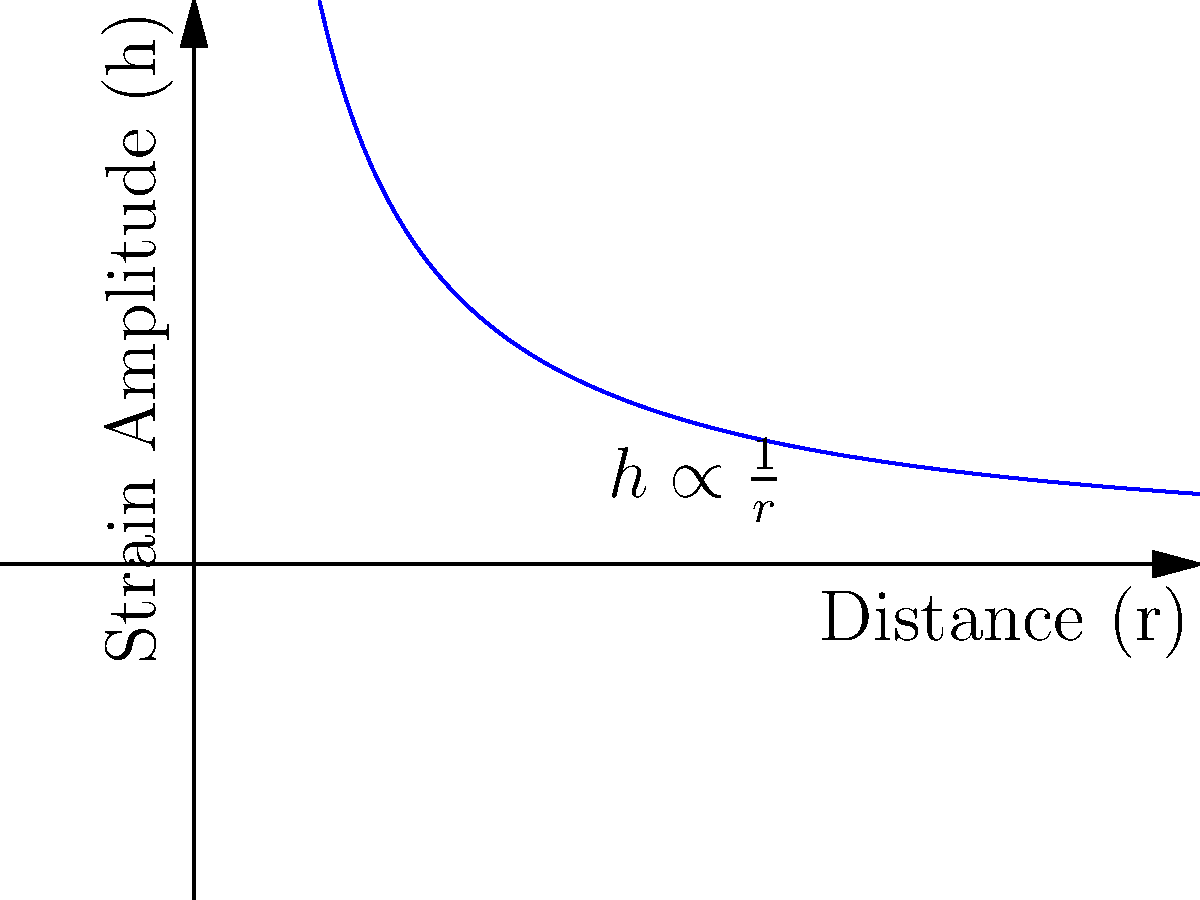Consider a gravitational wave source at a distance $r$ from an observer. If the strain amplitude $h$ of the gravitational wave is inversely proportional to the distance, how would the strain amplitude change if the observer moves to a position that is 3 times farther from the source? Let's approach this step-by-step:

1) We are given that the strain amplitude $h$ is inversely proportional to the distance $r$. This can be expressed mathematically as:

   $h \propto \frac{1}{r}$

2) Let's call the initial distance $r_1$ and the initial strain amplitude $h_1$. We can write:

   $h_1 = \frac{k}{r_1}$

   where $k$ is some constant of proportionality.

3) Now, the observer moves to a new position that is 3 times farther. Let's call this new distance $r_2$:

   $r_2 = 3r_1$

4) The new strain amplitude $h_2$ at this distance will be:

   $h_2 = \frac{k}{r_2} = \frac{k}{3r_1}$

5) To find how the strain amplitude changes, we can divide $h_2$ by $h_1$:

   $\frac{h_2}{h_1} = \frac{\frac{k}{3r_1}}{\frac{k}{r_1}} = \frac{1}{3}$

6) This means that $h_2 = \frac{1}{3}h_1$

Therefore, when the observer moves to a position 3 times farther from the source, the strain amplitude will decrease to one-third of its original value.
Answer: The strain amplitude decreases to $\frac{1}{3}$ of its original value. 